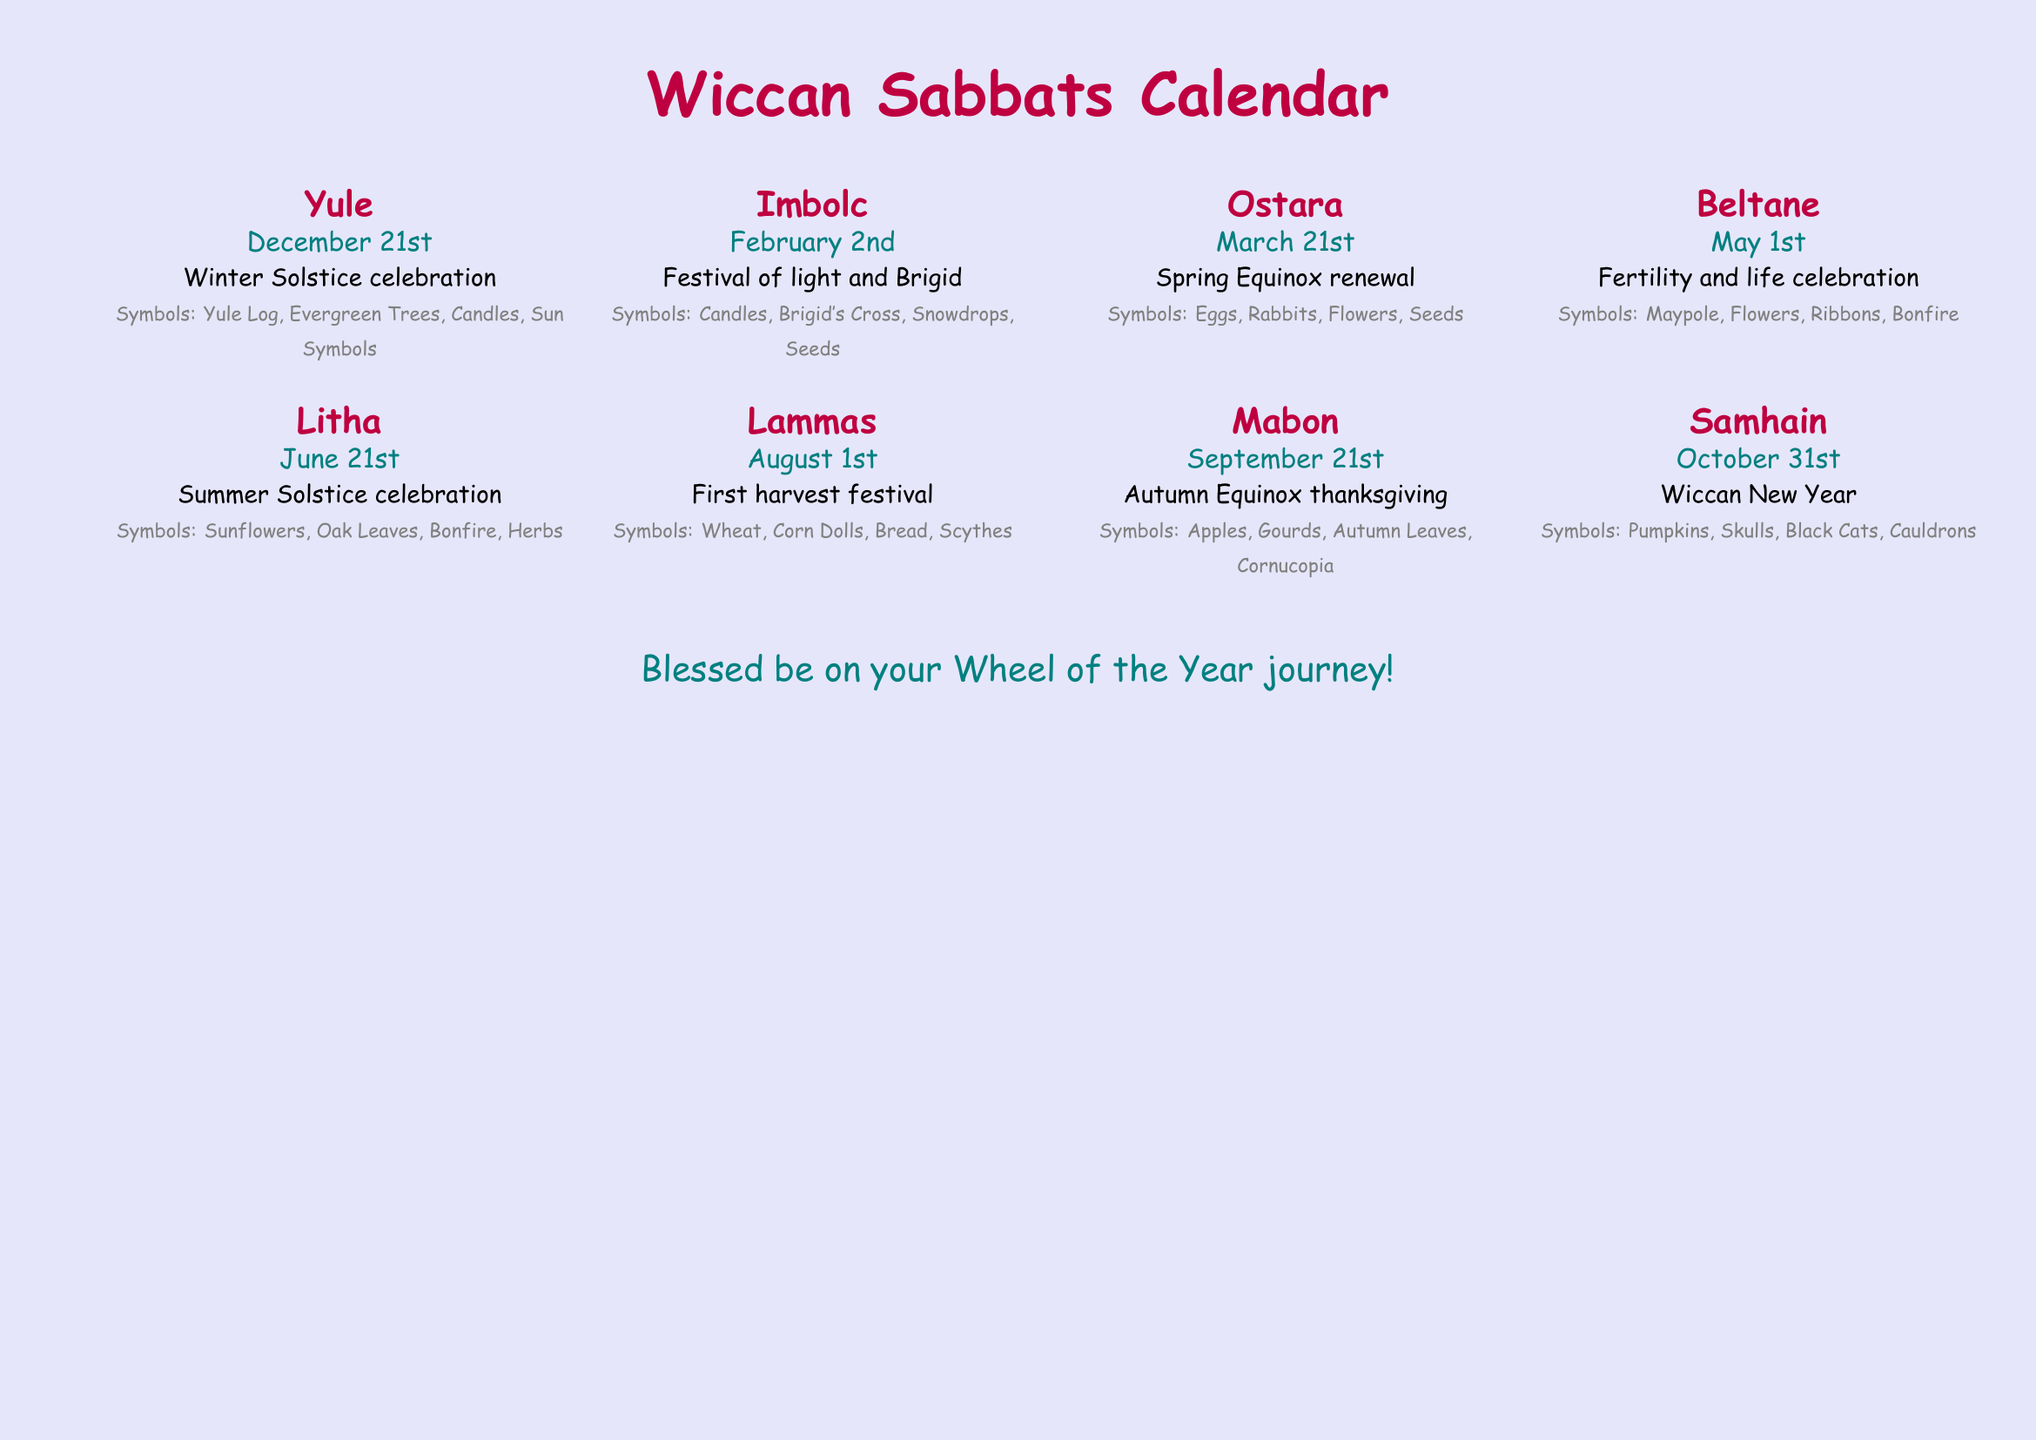What date marks Yule? Yule is celebrated on December 21st, as stated in the document.
Answer: December 21st How many Wiccan Sabbats are listed? The document lists a total of eight Wiccan Sabbats.
Answer: Eight What symbol is associated with Beltane? The document specifies several symbols associated with Beltane, one of which is the Maypole.
Answer: Maypole Which Sabbat occurs on August 1st? The document mentions that Lammas is the Sabbat celebrated on this date.
Answer: Lammas What is the celebration theme of Samhain? According to the document, Samhain is referred to as the Wiccan New Year.
Answer: Wiccan New Year What type of activity is associated with Imbolc? Imbolc features a festival of light, highlighting the importance of illumination.
Answer: Festival of light Which two symbols are mentioned for Mabon? The document lists apples and gourds as symbols associated with Mabon.
Answer: Apples, Gourds What is the significance of Litha? Litha marks the celebration of the Summer Solstice.
Answer: Summer Solstice celebration 